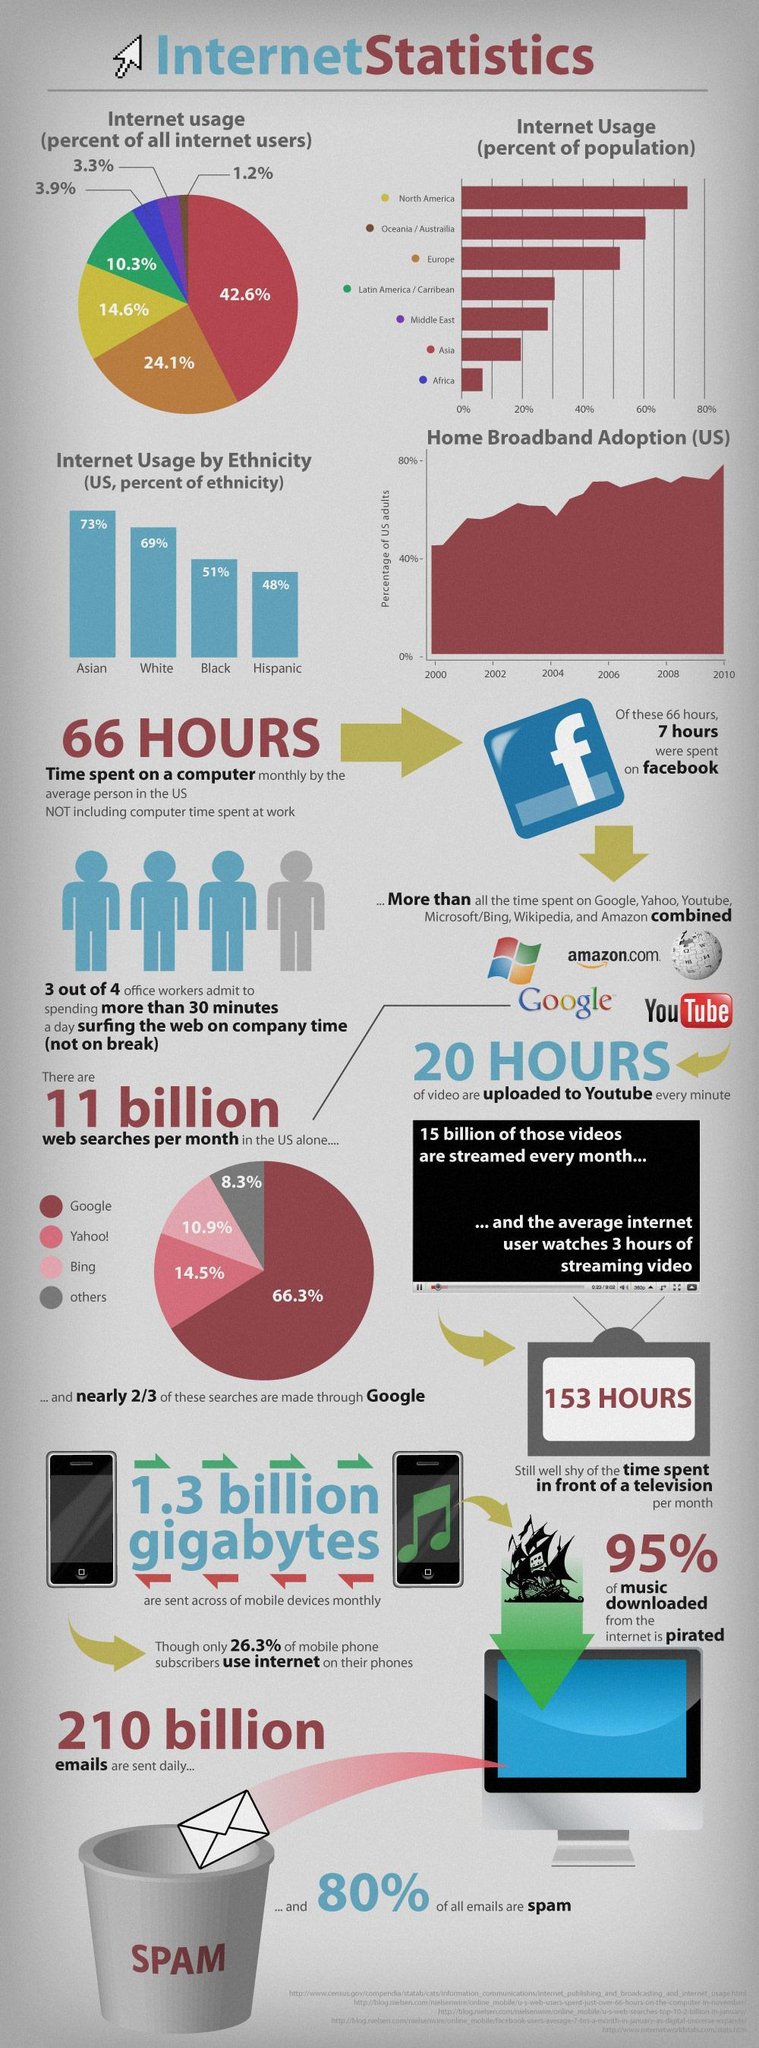What amount of videos are uploaded to Youtube every minute?
Answer the question with a short phrase. 20 Hours What percentage of music downloaded from the internet is pirated? 95% Which web search engine is used by 10.9% of people in U.S. per month? Bing What percentage of all emails send are not spam as per the internet statistics in U.S? 20% What percentage of emails are spam out of the 210 Billion emails sent on a daily basis? 80% What percentage of google searches per month were done in the U.S.? 66.3% How many emails are sent daily? 210 Billion How much time is spent on a computer monthly by the average person in the US not including computer time spent at work? 66 Hours Which web search engine is used by 14.5% of people in U.S. per month? Yahoo! Which ethnicity tops the internet usage? Asian 